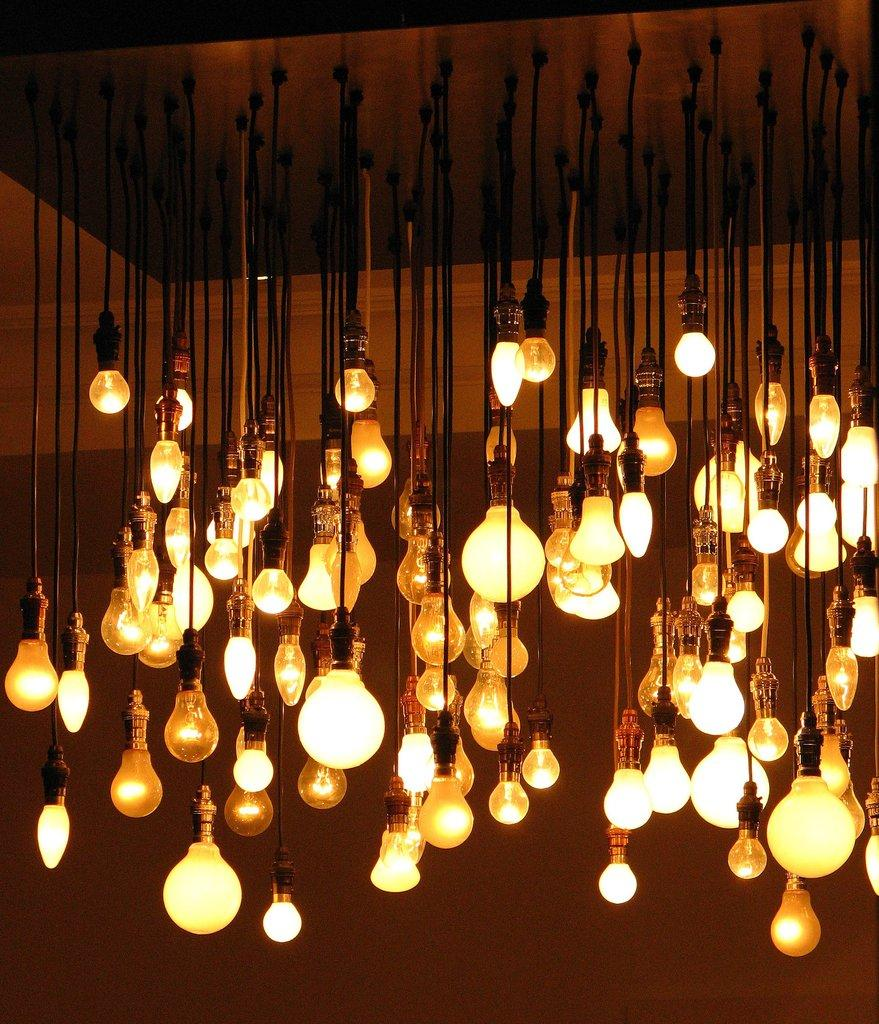What objects are present in the image? There are light bulbs in the image. Where are the light bulbs positioned? The light bulbs are hanging from the roof. How can the location of the light bulbs be described in relation to the image? The light bulbs are located in the center of the image. What type of volleyball game is being played in the image? There is no volleyball game present in the image; it features light bulbs hanging from the roof. How does friction affect the light bulbs in the image? There is no mention of friction in the image, as it only features light bulbs hanging from the roof. 